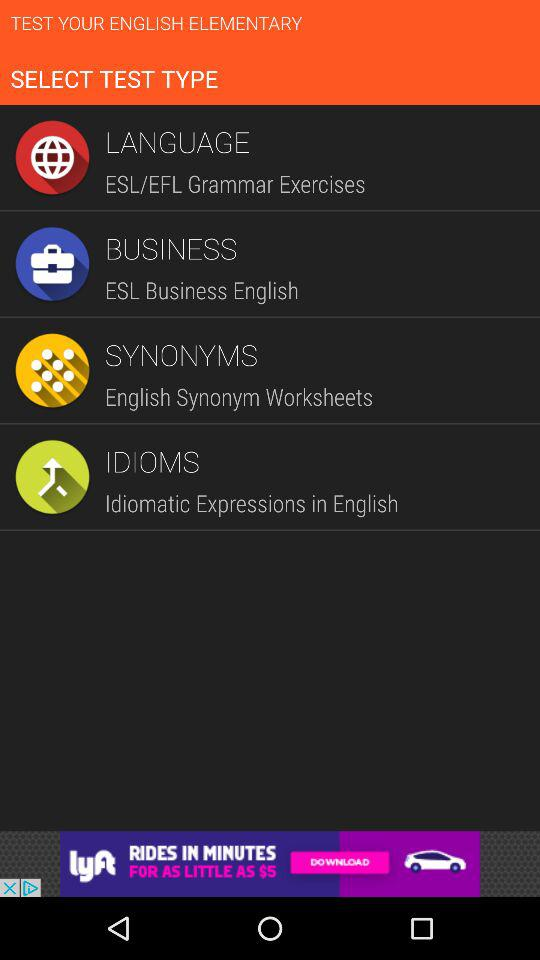What are the types of tests? The types of tests are "LANGUAGE", "BUSINESS", "SYNONYMS" and "IDIOMS". 